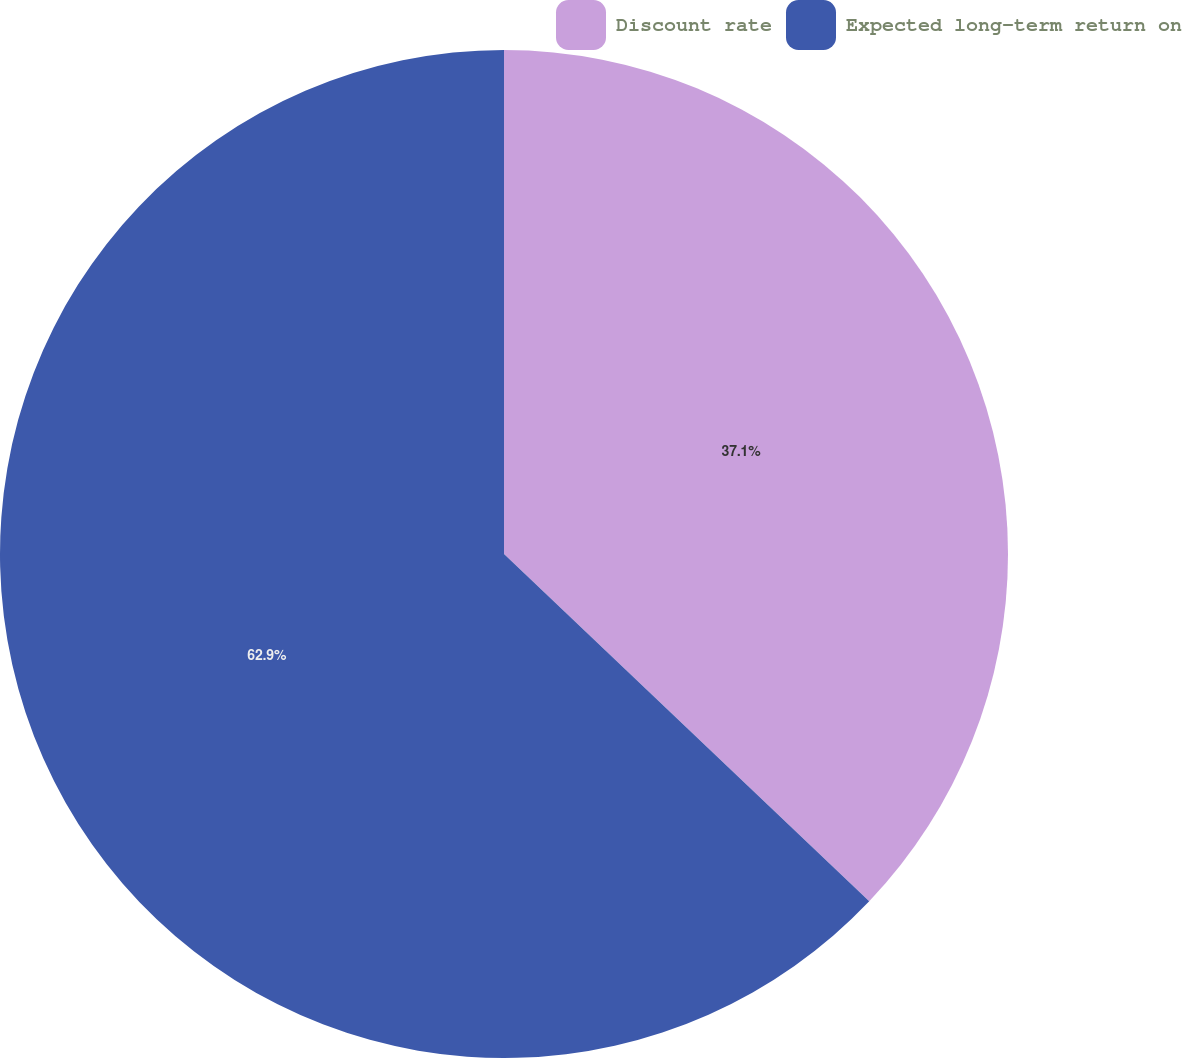Convert chart to OTSL. <chart><loc_0><loc_0><loc_500><loc_500><pie_chart><fcel>Discount rate<fcel>Expected long-term return on<nl><fcel>37.1%<fcel>62.9%<nl></chart> 